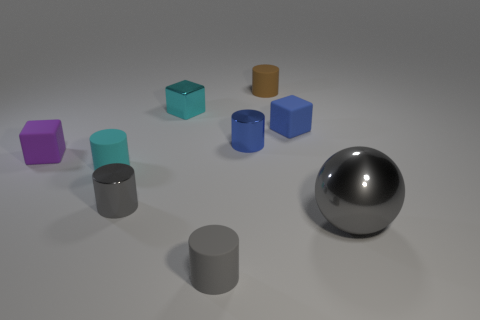What number of metallic things are the same color as the sphere?
Keep it short and to the point. 1. Are there any other things that are the same material as the large sphere?
Offer a very short reply. Yes. Are there fewer big metal things left of the tiny brown rubber thing than yellow metallic cylinders?
Offer a terse response. No. What is the color of the small matte block right of the shiny thing that is behind the blue shiny cylinder?
Make the answer very short. Blue. There is a matte block behind the matte block in front of the tiny blue object that is to the right of the tiny brown rubber cylinder; what is its size?
Ensure brevity in your answer.  Small. Are there fewer gray cylinders behind the small gray matte cylinder than small cyan cylinders that are left of the blue metallic thing?
Offer a very short reply. No. How many cyan blocks are made of the same material as the brown object?
Provide a short and direct response. 0. Is there a small rubber thing that is to the right of the rubber thing that is in front of the tiny cyan rubber thing behind the gray sphere?
Offer a terse response. Yes. What is the shape of the tiny gray object that is the same material as the tiny blue cylinder?
Ensure brevity in your answer.  Cylinder. Is the number of large metal objects greater than the number of small objects?
Make the answer very short. No. 